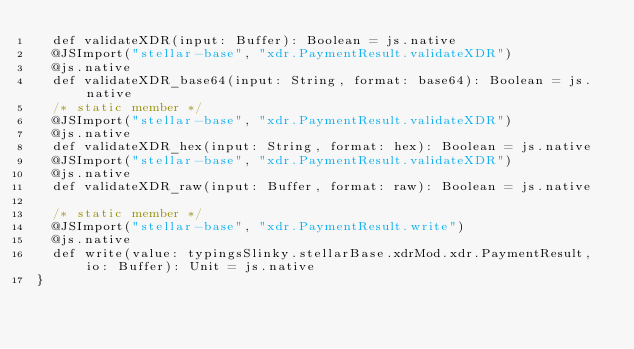<code> <loc_0><loc_0><loc_500><loc_500><_Scala_>  def validateXDR(input: Buffer): Boolean = js.native
  @JSImport("stellar-base", "xdr.PaymentResult.validateXDR")
  @js.native
  def validateXDR_base64(input: String, format: base64): Boolean = js.native
  /* static member */
  @JSImport("stellar-base", "xdr.PaymentResult.validateXDR")
  @js.native
  def validateXDR_hex(input: String, format: hex): Boolean = js.native
  @JSImport("stellar-base", "xdr.PaymentResult.validateXDR")
  @js.native
  def validateXDR_raw(input: Buffer, format: raw): Boolean = js.native
  
  /* static member */
  @JSImport("stellar-base", "xdr.PaymentResult.write")
  @js.native
  def write(value: typingsSlinky.stellarBase.xdrMod.xdr.PaymentResult, io: Buffer): Unit = js.native
}
</code> 